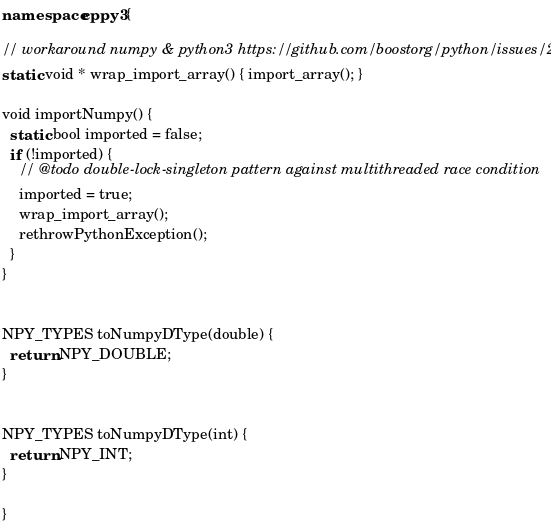<code> <loc_0><loc_0><loc_500><loc_500><_C++_>namespace cppy3 {

// workaround numpy & python3 https://github.com/boostorg/python/issues/214
static void * wrap_import_array() { import_array(); }

void importNumpy() {
  static bool imported = false;
  if (!imported) {
    // @todo double-lock-singleton pattern against multithreaded race condition
    imported = true;
    wrap_import_array();
    rethrowPythonException();
  }
}


NPY_TYPES toNumpyDType(double) {
  return NPY_DOUBLE;
}


NPY_TYPES toNumpyDType(int) {
  return NPY_INT;
}

}

</code> 